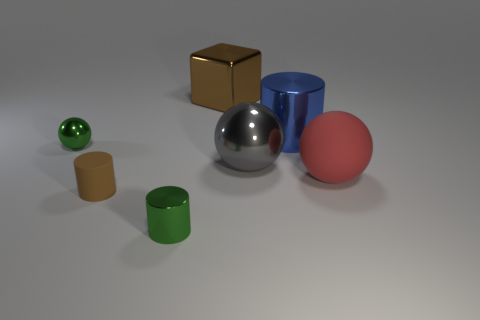There is a brown object left of the big brown shiny block; what size is it?
Make the answer very short. Small. How many gray things are the same size as the green shiny ball?
Provide a succinct answer. 0. There is a shiny thing that is the same color as the tiny rubber cylinder; what is its size?
Your response must be concise. Large. Is there a metal cylinder that has the same color as the small ball?
Make the answer very short. Yes. There is a cylinder that is the same size as the brown metallic object; what color is it?
Keep it short and to the point. Blue. Do the block and the matte object that is left of the large block have the same color?
Your answer should be very brief. Yes. What is the color of the rubber cylinder?
Your answer should be very brief. Brown. What material is the brown thing that is right of the tiny green shiny cylinder?
Give a very brief answer. Metal. What is the size of the green object that is the same shape as the blue object?
Your answer should be compact. Small. Is the number of small metal cylinders that are behind the tiny matte cylinder less than the number of large cyan balls?
Your answer should be compact. No. 